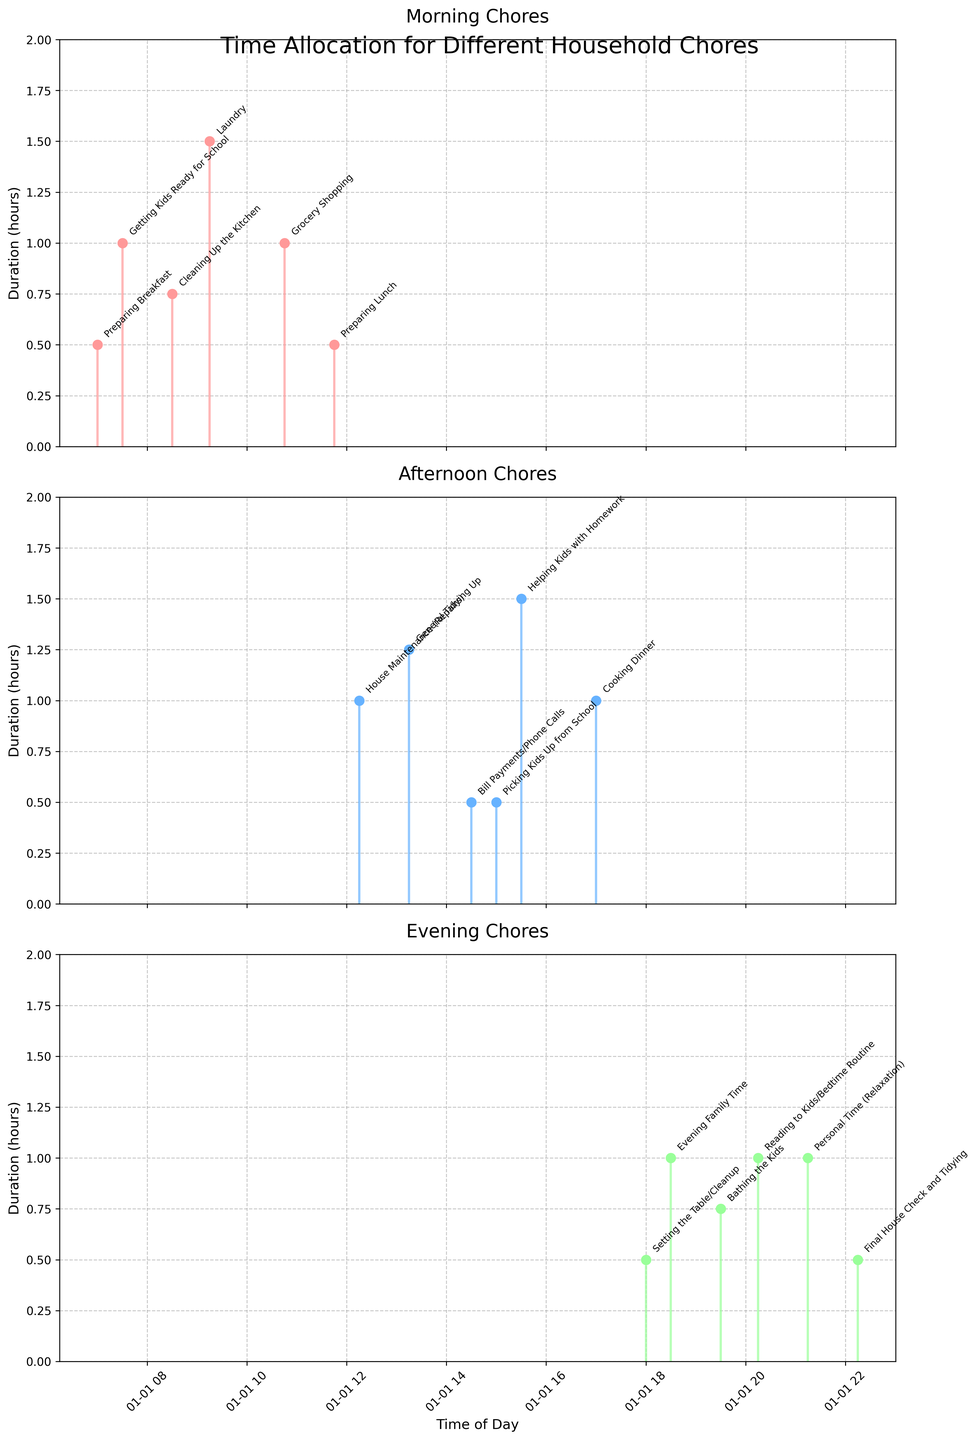What time of day is the "Preparing Breakfast" chore done? The "Preparing Breakfast" chore is plotted in the first subplot labeled "Morning Chores". In the figure, the "Preparing Breakfast" data point is positioned at 7:00 on the x-axis.
Answer: 7:00 How many total hours are spent on chores in the "Afternoon Chores" subplot? In the "Afternoon Chores" subplot, durations are summed as follows: 0.5 (Preparing Lunch) + 1 (House Maintenance) + 1.25 (General Tidying Up) + 0.5 (Bill Payments/Phone Calls) + 0.5 (Picking Kids Up from School) + 1.5 (Helping Kids with Homework) = 5.25 hours.
Answer: 5.25 hours Which chore has the longest duration in the "Evening Chores" subplot? The "Evening Chores" subplot shows several activities, and by observing the corresponding durations, the chore "Helping Kids with Homework" is identified as having the longest duration, marked at 1.5 hours.
Answer: Helping Kids with Homework How does the duration of "Laundry" compare to "Grocery Shopping"? "Laundry" (Morning Chores) has a duration of 1.5 hours, whereas "Grocery Shopping" (Morning Chores) has a duration of 1 hour. Laundry takes longer by 0.5 hours.
Answer: Laundry takes longer by 0.5 hours What is the sum of time spent on "General Tidying Up" and "Bill Payments/Phone Calls"? In the "Afternoon Chores" subplot, the durations for "General Tidying Up" and "Bill Payments/Phone Calls" are 1.25 and 0.5 hours, respectively. Summing them yields: 1.25 + 0.5 = 1.75 hours.
Answer: 1.75 hours Which time period (Morning, Afternoon, or Evening) has the highest total duration of chores? Sum the durations for each period: Morning: 0.5 (Preparing Breakfast) + 1 (Getting Kids Ready for School) + 0.75 (Cleaning Up the Kitchen) + 1.5 (Laundry) + 1 (Grocery Shopping) = 4.75 hours. Afternoon: 0.5 (Preparing Lunch) + 1 (House Maintenance) + 1.25 (General Tidying Up) + 0.5 (Bill Payments/Phone Calls) + 0.5 (Picking Kids Up from School) + 1.5 (Helping Kids with Homework) = 5.25 hours. Evening: 1 (Cooking Dinner) + 0.5 (Setting the Table/Cleanup) + 1 (Evening Family Time) + 0.75 (Bathing the Kids) + 1 (Reading to Kids/Bedtime Routine) + 1 (Personal Time) + 0.5 (Final House Check and Tidying) = 5.75 hours. Therefore, Evening has the highest total duration.
Answer: Evening What is the average duration of chores in the "Morning Chores" subplot? The total duration of Morning Chores is 0.5 (Preparing Breakfast) + 1 (Getting Kids Ready for School) + 0.75 (Cleaning Up the Kitchen) + 1.5 (Laundry) + 1 (Grocery Shopping) = 4.75 hours. There are 5 chores, so the average duration is 4.75 / 5 = 0.95 hours.
Answer: 0.95 hours What chore is plotted immediately after "Setting the Table/Cleanup"? In the "Evening Chores" subplot, following the "Setting the Table/Cleanup" with a duration of 0.5 hours at 18:00, the next chore plotted is "Evening Family Time" at 18:30.
Answer: Evening Family Time 